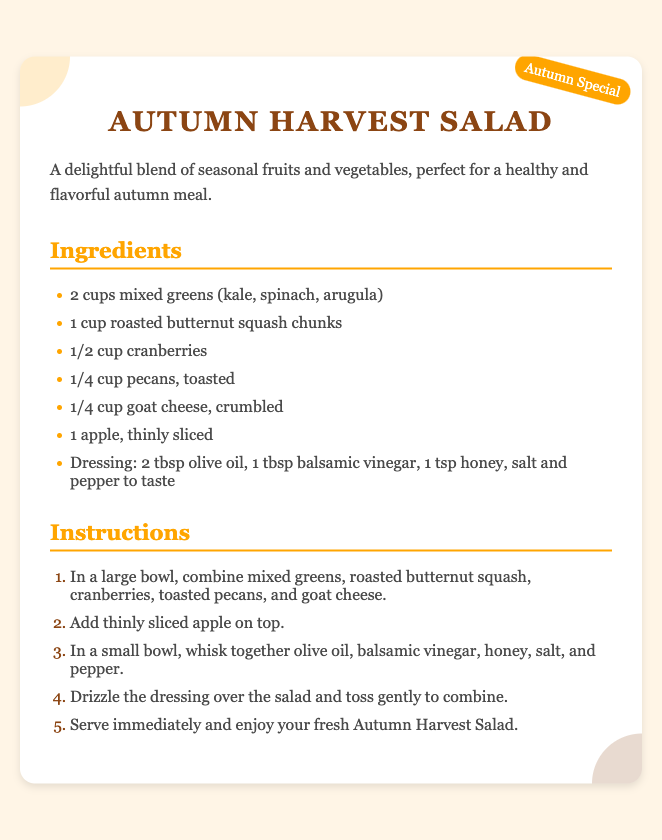What is the name of the recipe? The title of the recipe is prominently displayed as "Autumn Harvest Salad."
Answer: Autumn Harvest Salad How many cups of mixed greens are needed? The ingredients list states that 2 cups of mixed greens are required.
Answer: 2 cups What type of cheese is used in the salad? The ingredients specify "goat cheese" as the cheese in the recipe.
Answer: Goat cheese What seasoning is included in the dressing? The dressing ingredients list includes "honey" as one of the components.
Answer: Honey How many steps are in the instructions? The instructions list contains 5 distinct steps for preparing the salad.
Answer: 5 What is the seasonal theme of this recipe? The seasonal stamp indicates that this recipe is an "Autumn Special."
Answer: Autumn Special What is the color of the background in the recipe card? The background color of the recipe card is indicated to be "#FFF5E6," which is a light shade.
Answer: Light shade Which nut is included in the salad? The ingredients mention "pecans" as the nut included in the salad.
Answer: Pecans What is the first step in the instructions? The first instruction states to combine mixed greens, roasted butternut squash, cranberries, toasted pecans, and goat cheese in a large bowl.
Answer: Combine ingredients in a large bowl 